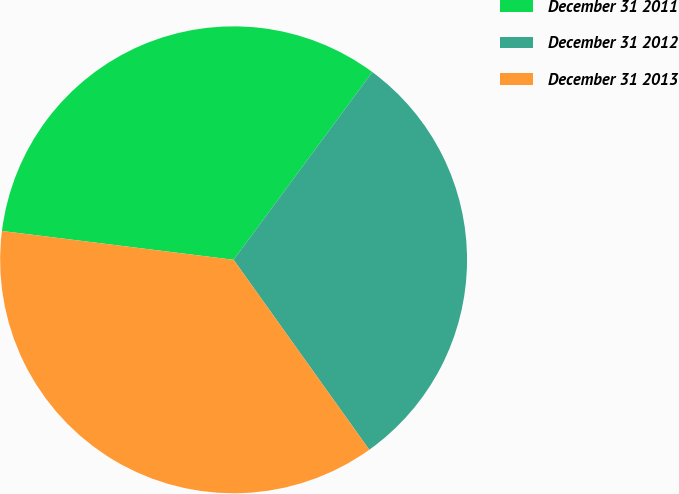Convert chart to OTSL. <chart><loc_0><loc_0><loc_500><loc_500><pie_chart><fcel>December 31 2011<fcel>December 31 2012<fcel>December 31 2013<nl><fcel>33.16%<fcel>30.0%<fcel>36.84%<nl></chart> 